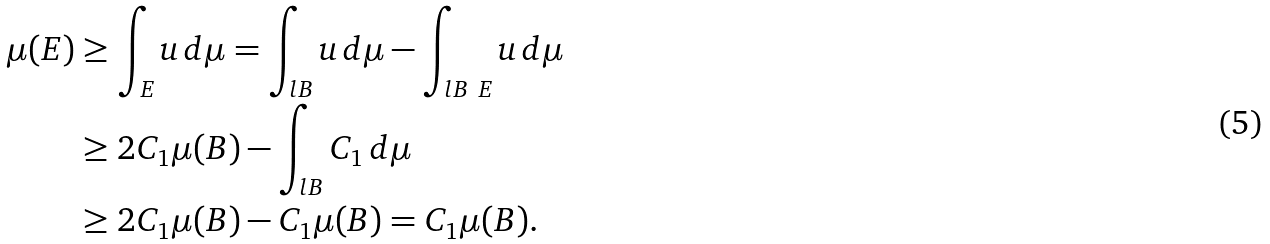Convert formula to latex. <formula><loc_0><loc_0><loc_500><loc_500>\mu ( E ) & \geq \int _ { E } u \, d \mu = \int _ { l B } u \, d \mu - \int _ { l B \ E } u \, d \mu \\ & \geq 2 C _ { 1 } \mu ( B ) - \int _ { l B } C _ { 1 } \, d \mu \\ & \geq 2 C _ { 1 } \mu ( B ) - C _ { 1 } \mu ( B ) = C _ { 1 } \mu ( B ) .</formula> 